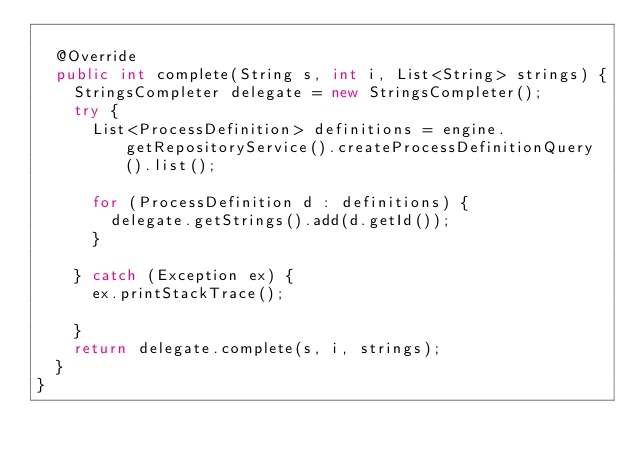Convert code to text. <code><loc_0><loc_0><loc_500><loc_500><_Java_>
  @Override
  public int complete(String s, int i, List<String> strings) {
    StringsCompleter delegate = new StringsCompleter();
    try {
      List<ProcessDefinition> definitions = engine.getRepositoryService().createProcessDefinitionQuery().list();

      for (ProcessDefinition d : definitions) {
        delegate.getStrings().add(d.getId());
      }

    } catch (Exception ex) {
      ex.printStackTrace();

    }
    return delegate.complete(s, i, strings);
  }
}
</code> 